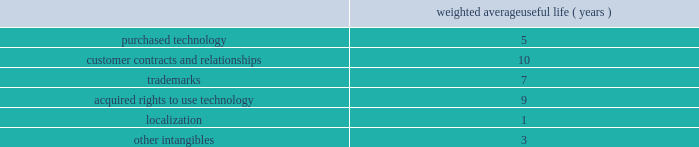Goodwill is assigned to one or more reporting segments on the date of acquisition .
We evaluate goodwill for impairment by comparing the fair value of each of our reporting segments to its carrying value , including the associated goodwill .
To determine the fair values , we use the market approach based on comparable publicly traded companies in similar lines of businesses and the income approach based on estimated discounted future cash flows .
Our cash flow assumptions consider historical and forecasted revenue , operating costs and other relevant factors .
We amortize intangible assets with finite lives over their estimated useful lives and review them for impairment whenever an impairment indicator exists .
We continually monitor events and changes in circumstances that could indicate carrying amounts of our long-lived assets , including our intangible assets may not be recoverable .
When such events or changes in circumstances occur , we assess recoverability by determining whether the carrying value of such assets will be recovered through the undiscounted expected future cash flows .
If the future undiscounted cash flows are less than the carrying amount of these assets , we recognize an impairment loss based on any excess of the carrying amount over the fair value of the assets .
We did not recognize any intangible asset impairment charges in fiscal 2012 , 2011 or 2010 .
Our intangible assets are amortized over their estimated useful lives of 1 to 13 years .
Amortization is based on the pattern in which the economic benefits of the intangible asset will be consumed .
The weighted average useful lives of our intangible assets was as follows : weighted average useful life ( years ) .
Software development costs capitalization of software development costs for software to be sold , leased , or otherwise marketed begins upon the establishment of technological feasibility , which is generally the completion of a working prototype that has been certified as having no critical bugs and is a release candidate .
Amortization begins once the software is ready for its intended use , generally based on the pattern in which the economic benefits will be consumed .
To date , software development costs incurred between completion of a working prototype and general availability of the related product have not been material .
Internal use software we capitalize costs associated with customized internal-use software systems that have reached the application development stage .
Such capitalized costs include external direct costs utilized in developing or obtaining the applications and payroll and payroll-related expenses for employees , who are directly associated with the development of the applications .
Capitalization of such costs begins when the preliminary project stage is complete and ceases at the point in which the project is substantially complete and is ready for its intended purpose .
Income taxes we use the asset and liability method of accounting for income taxes .
Under this method , income tax expense is recognized for the amount of taxes payable or refundable for the current year .
In addition , deferred tax assets and liabilities are recognized for expected future tax consequences of temporary differences between the financial reporting and tax bases of assets and liabilities , and for operating losses and tax credit carryforwards .
We record a valuation allowance to reduce deferred tax assets to an amount for which realization is more likely than not .
Table of contents adobe systems incorporated notes to consolidated financial statements ( continued ) .
What is the average weighted average useful life ( years ) for purchased technology and customer contracts and relationships? 
Computations: ((5 + 10) / 2)
Answer: 7.5. 